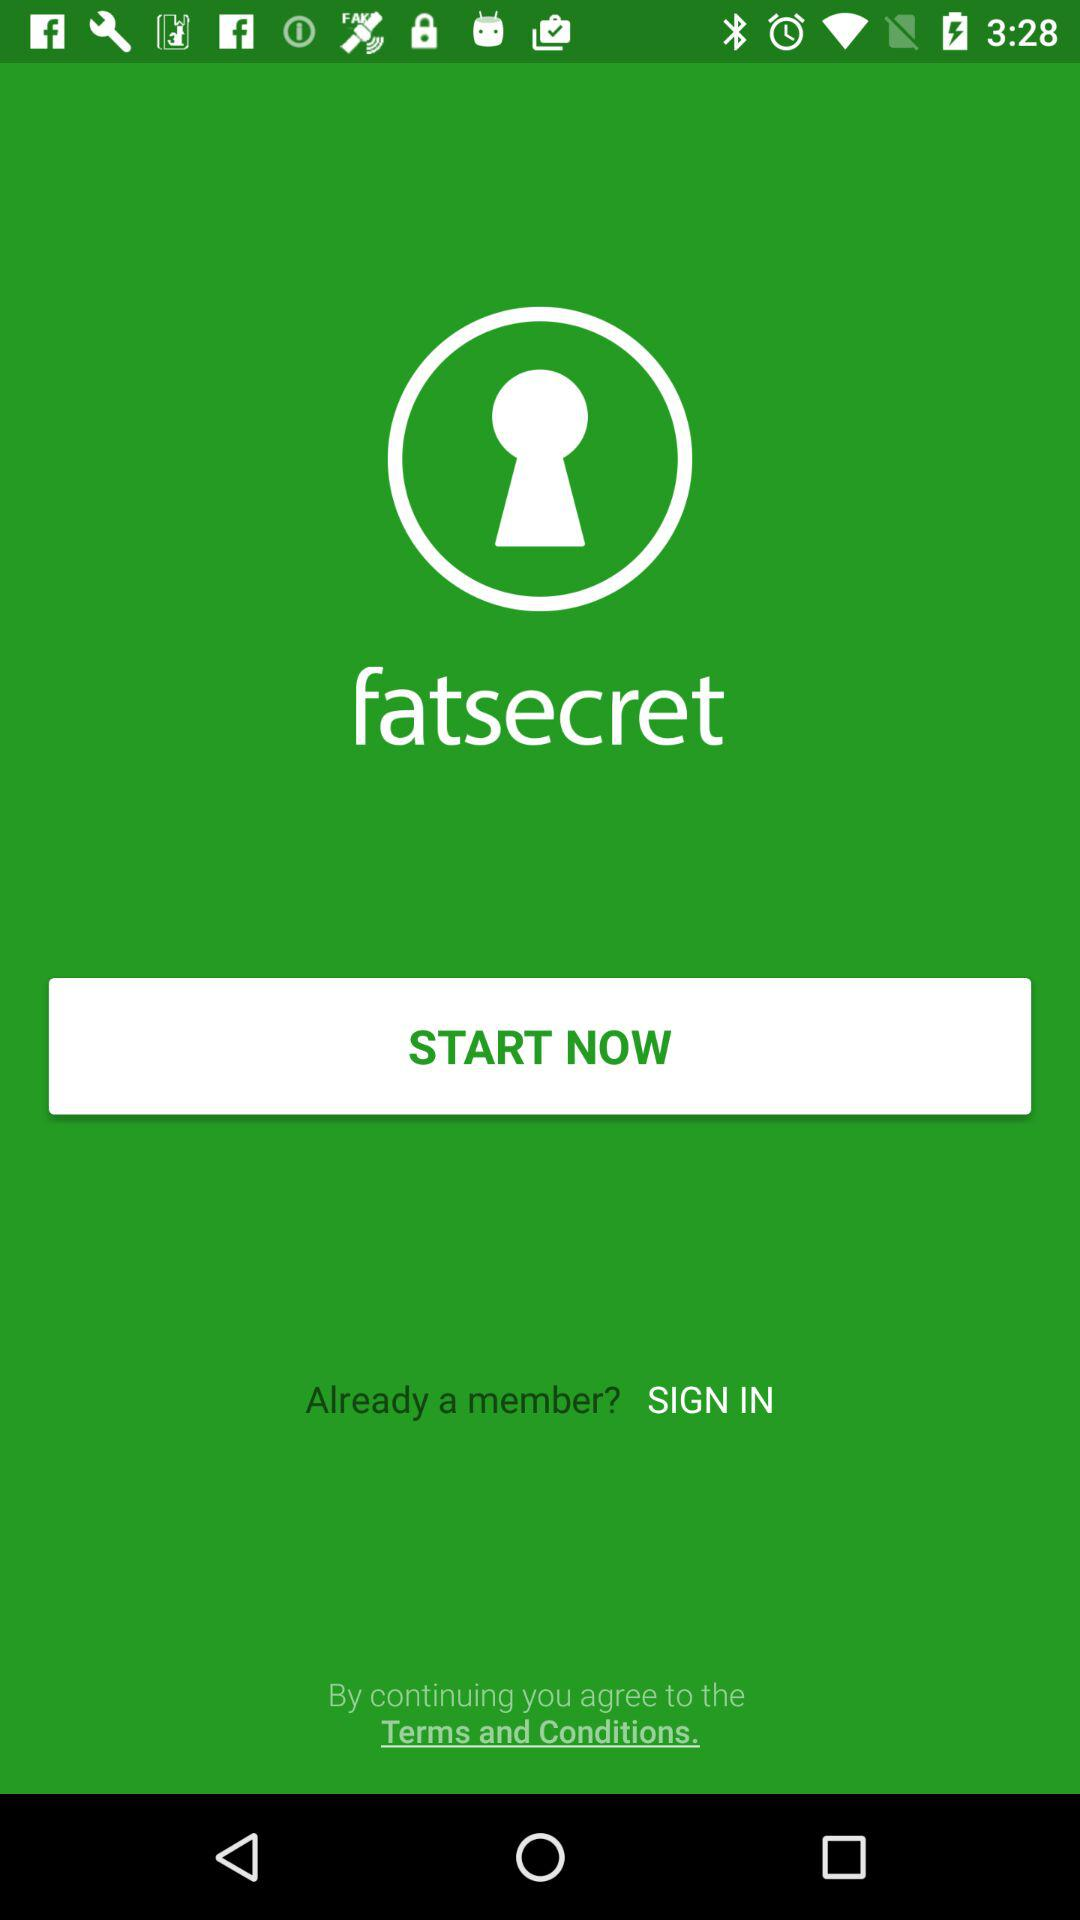What is the name of the application? The name of the application is "fatsecret". 